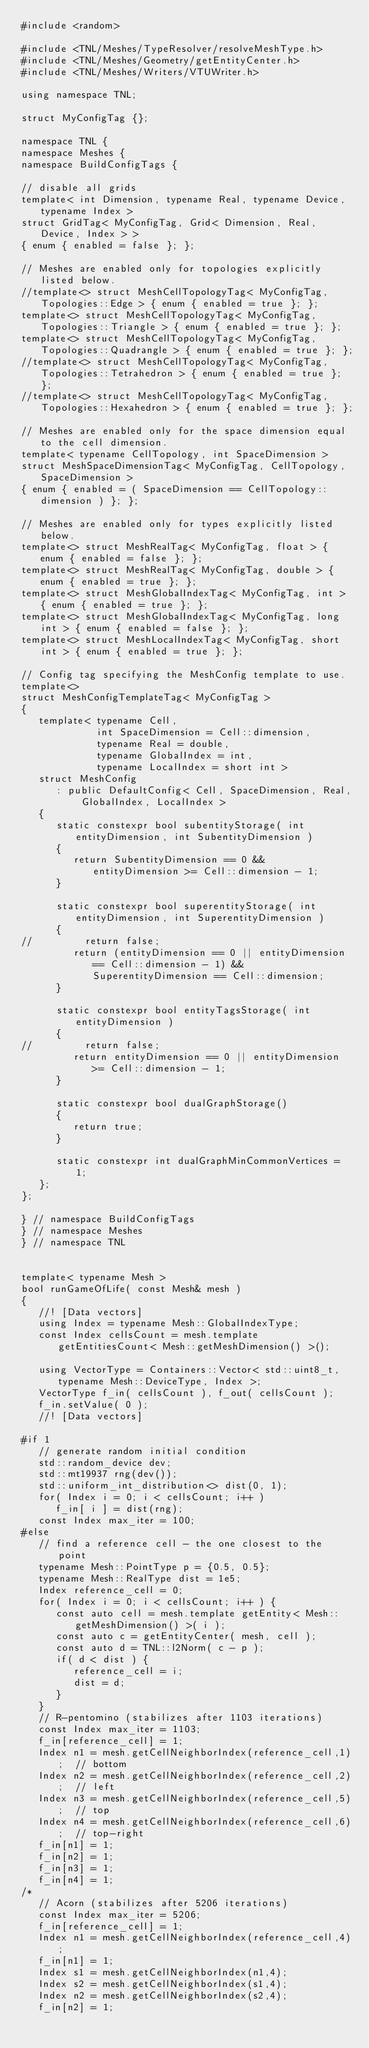<code> <loc_0><loc_0><loc_500><loc_500><_Cuda_>#include <random>

#include <TNL/Meshes/TypeResolver/resolveMeshType.h>
#include <TNL/Meshes/Geometry/getEntityCenter.h>
#include <TNL/Meshes/Writers/VTUWriter.h>

using namespace TNL;

struct MyConfigTag {};

namespace TNL {
namespace Meshes {
namespace BuildConfigTags {

// disable all grids
template< int Dimension, typename Real, typename Device, typename Index >
struct GridTag< MyConfigTag, Grid< Dimension, Real, Device, Index > >
{ enum { enabled = false }; };

// Meshes are enabled only for topologies explicitly listed below.
//template<> struct MeshCellTopologyTag< MyConfigTag, Topologies::Edge > { enum { enabled = true }; };
template<> struct MeshCellTopologyTag< MyConfigTag, Topologies::Triangle > { enum { enabled = true }; };
template<> struct MeshCellTopologyTag< MyConfigTag, Topologies::Quadrangle > { enum { enabled = true }; };
//template<> struct MeshCellTopologyTag< MyConfigTag, Topologies::Tetrahedron > { enum { enabled = true }; };
//template<> struct MeshCellTopologyTag< MyConfigTag, Topologies::Hexahedron > { enum { enabled = true }; };

// Meshes are enabled only for the space dimension equal to the cell dimension.
template< typename CellTopology, int SpaceDimension >
struct MeshSpaceDimensionTag< MyConfigTag, CellTopology, SpaceDimension >
{ enum { enabled = ( SpaceDimension == CellTopology::dimension ) }; };

// Meshes are enabled only for types explicitly listed below.
template<> struct MeshRealTag< MyConfigTag, float > { enum { enabled = false }; };
template<> struct MeshRealTag< MyConfigTag, double > { enum { enabled = true }; };
template<> struct MeshGlobalIndexTag< MyConfigTag, int > { enum { enabled = true }; };
template<> struct MeshGlobalIndexTag< MyConfigTag, long int > { enum { enabled = false }; };
template<> struct MeshLocalIndexTag< MyConfigTag, short int > { enum { enabled = true }; };

// Config tag specifying the MeshConfig template to use.
template<>
struct MeshConfigTemplateTag< MyConfigTag >
{
   template< typename Cell,
             int SpaceDimension = Cell::dimension,
             typename Real = double,
             typename GlobalIndex = int,
             typename LocalIndex = short int >
   struct MeshConfig
      : public DefaultConfig< Cell, SpaceDimension, Real, GlobalIndex, LocalIndex >
   {
      static constexpr bool subentityStorage( int entityDimension, int SubentityDimension )
      {
         return SubentityDimension == 0 && entityDimension >= Cell::dimension - 1;
      }

      static constexpr bool superentityStorage( int entityDimension, int SuperentityDimension )
      {
//         return false;
         return (entityDimension == 0 || entityDimension == Cell::dimension - 1) && SuperentityDimension == Cell::dimension;
      }

      static constexpr bool entityTagsStorage( int entityDimension )
      {
//         return false;
         return entityDimension == 0 || entityDimension >= Cell::dimension - 1;
      }

      static constexpr bool dualGraphStorage()
      {
         return true;
      }

      static constexpr int dualGraphMinCommonVertices = 1;
   };
};

} // namespace BuildConfigTags
} // namespace Meshes
} // namespace TNL


template< typename Mesh >
bool runGameOfLife( const Mesh& mesh )
{
   //! [Data vectors]
   using Index = typename Mesh::GlobalIndexType;
   const Index cellsCount = mesh.template getEntitiesCount< Mesh::getMeshDimension() >();

   using VectorType = Containers::Vector< std::uint8_t, typename Mesh::DeviceType, Index >;
   VectorType f_in( cellsCount ), f_out( cellsCount );
   f_in.setValue( 0 );
   //! [Data vectors]

#if 1
   // generate random initial condition
   std::random_device dev;
   std::mt19937 rng(dev());
   std::uniform_int_distribution<> dist(0, 1);
   for( Index i = 0; i < cellsCount; i++ )
      f_in[ i ] = dist(rng);
   const Index max_iter = 100;
#else
   // find a reference cell - the one closest to the point
   typename Mesh::PointType p = {0.5, 0.5};
   typename Mesh::RealType dist = 1e5;
   Index reference_cell = 0;
   for( Index i = 0; i < cellsCount; i++ ) {
      const auto cell = mesh.template getEntity< Mesh::getMeshDimension() >( i );
      const auto c = getEntityCenter( mesh, cell );
      const auto d = TNL::l2Norm( c - p );
      if( d < dist ) {
         reference_cell = i;
         dist = d;
      }
   }
   // R-pentomino (stabilizes after 1103 iterations)
   const Index max_iter = 1103;
   f_in[reference_cell] = 1;
   Index n1 = mesh.getCellNeighborIndex(reference_cell,1);  // bottom
   Index n2 = mesh.getCellNeighborIndex(reference_cell,2);  // left
   Index n3 = mesh.getCellNeighborIndex(reference_cell,5);  // top
   Index n4 = mesh.getCellNeighborIndex(reference_cell,6);  // top-right
   f_in[n1] = 1;
   f_in[n2] = 1;
   f_in[n3] = 1;
   f_in[n4] = 1;
/*
   // Acorn (stabilizes after 5206 iterations)
   const Index max_iter = 5206;
   f_in[reference_cell] = 1;
   Index n1 = mesh.getCellNeighborIndex(reference_cell,4);
   f_in[n1] = 1;
   Index s1 = mesh.getCellNeighborIndex(n1,4);
   Index s2 = mesh.getCellNeighborIndex(s1,4);
   Index n2 = mesh.getCellNeighborIndex(s2,4);
   f_in[n2] = 1;</code> 